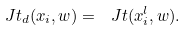<formula> <loc_0><loc_0><loc_500><loc_500>\ J t _ { d } ( x _ { i } , w ) = \ J t ( x ^ { l } _ { i } , w ) .</formula> 